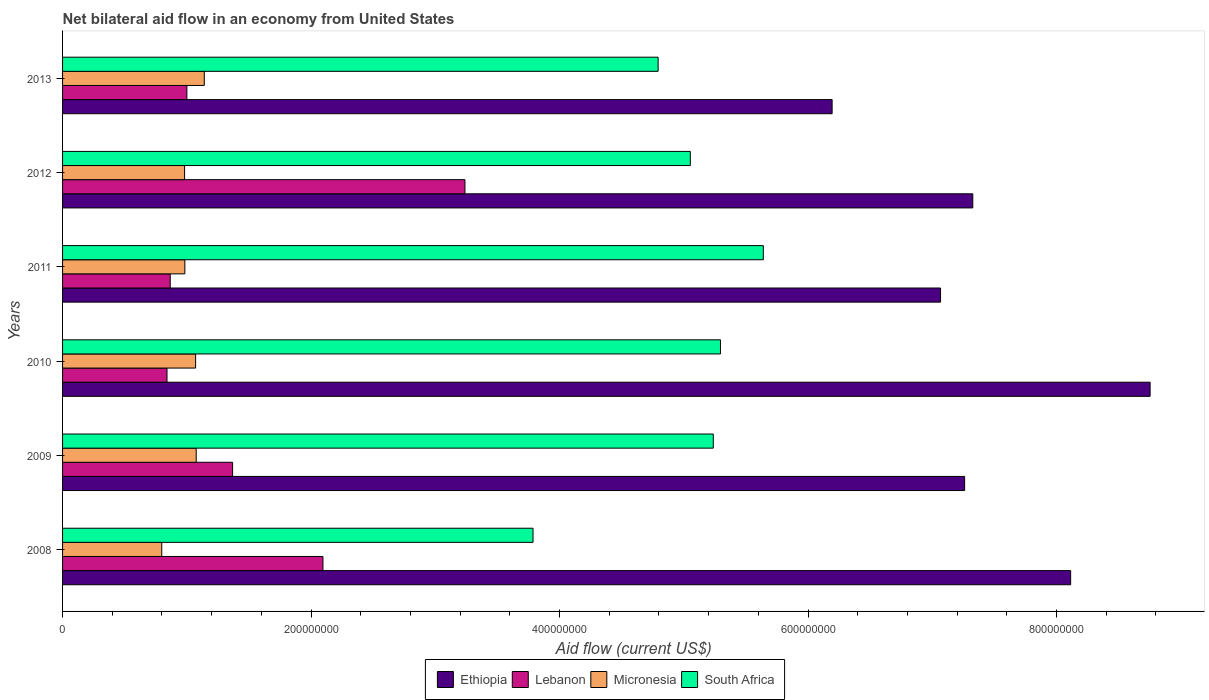How many groups of bars are there?
Make the answer very short. 6. Are the number of bars per tick equal to the number of legend labels?
Give a very brief answer. Yes. How many bars are there on the 1st tick from the top?
Keep it short and to the point. 4. What is the label of the 5th group of bars from the top?
Give a very brief answer. 2009. What is the net bilateral aid flow in Micronesia in 2013?
Your answer should be very brief. 1.14e+08. Across all years, what is the maximum net bilateral aid flow in Lebanon?
Make the answer very short. 3.24e+08. Across all years, what is the minimum net bilateral aid flow in Lebanon?
Offer a terse response. 8.40e+07. In which year was the net bilateral aid flow in South Africa minimum?
Offer a very short reply. 2008. What is the total net bilateral aid flow in Micronesia in the graph?
Make the answer very short. 6.05e+08. What is the difference between the net bilateral aid flow in Lebanon in 2008 and that in 2012?
Your answer should be compact. -1.14e+08. What is the difference between the net bilateral aid flow in Micronesia in 2009 and the net bilateral aid flow in Lebanon in 2011?
Provide a short and direct response. 2.09e+07. What is the average net bilateral aid flow in Lebanon per year?
Your answer should be very brief. 1.57e+08. In the year 2009, what is the difference between the net bilateral aid flow in Lebanon and net bilateral aid flow in Micronesia?
Offer a terse response. 2.93e+07. In how many years, is the net bilateral aid flow in Ethiopia greater than 560000000 US$?
Give a very brief answer. 6. What is the ratio of the net bilateral aid flow in Lebanon in 2011 to that in 2012?
Keep it short and to the point. 0.27. What is the difference between the highest and the second highest net bilateral aid flow in Micronesia?
Offer a very short reply. 6.52e+06. What is the difference between the highest and the lowest net bilateral aid flow in South Africa?
Offer a terse response. 1.85e+08. In how many years, is the net bilateral aid flow in South Africa greater than the average net bilateral aid flow in South Africa taken over all years?
Your answer should be very brief. 4. Is the sum of the net bilateral aid flow in Ethiopia in 2008 and 2012 greater than the maximum net bilateral aid flow in Micronesia across all years?
Make the answer very short. Yes. What does the 1st bar from the top in 2012 represents?
Offer a terse response. South Africa. What does the 1st bar from the bottom in 2012 represents?
Offer a terse response. Ethiopia. Are all the bars in the graph horizontal?
Provide a short and direct response. Yes. Does the graph contain any zero values?
Your response must be concise. No. Where does the legend appear in the graph?
Make the answer very short. Bottom center. How many legend labels are there?
Keep it short and to the point. 4. How are the legend labels stacked?
Your answer should be very brief. Horizontal. What is the title of the graph?
Your answer should be very brief. Net bilateral aid flow in an economy from United States. What is the label or title of the X-axis?
Ensure brevity in your answer.  Aid flow (current US$). What is the label or title of the Y-axis?
Provide a succinct answer. Years. What is the Aid flow (current US$) in Ethiopia in 2008?
Your response must be concise. 8.11e+08. What is the Aid flow (current US$) in Lebanon in 2008?
Keep it short and to the point. 2.10e+08. What is the Aid flow (current US$) of Micronesia in 2008?
Offer a very short reply. 7.98e+07. What is the Aid flow (current US$) in South Africa in 2008?
Provide a short and direct response. 3.79e+08. What is the Aid flow (current US$) of Ethiopia in 2009?
Your answer should be compact. 7.26e+08. What is the Aid flow (current US$) in Lebanon in 2009?
Give a very brief answer. 1.37e+08. What is the Aid flow (current US$) of Micronesia in 2009?
Your answer should be compact. 1.08e+08. What is the Aid flow (current US$) in South Africa in 2009?
Give a very brief answer. 5.24e+08. What is the Aid flow (current US$) of Ethiopia in 2010?
Offer a very short reply. 8.75e+08. What is the Aid flow (current US$) of Lebanon in 2010?
Make the answer very short. 8.40e+07. What is the Aid flow (current US$) in Micronesia in 2010?
Offer a terse response. 1.07e+08. What is the Aid flow (current US$) of South Africa in 2010?
Make the answer very short. 5.30e+08. What is the Aid flow (current US$) of Ethiopia in 2011?
Provide a short and direct response. 7.07e+08. What is the Aid flow (current US$) of Lebanon in 2011?
Give a very brief answer. 8.67e+07. What is the Aid flow (current US$) in Micronesia in 2011?
Your response must be concise. 9.84e+07. What is the Aid flow (current US$) of South Africa in 2011?
Give a very brief answer. 5.64e+08. What is the Aid flow (current US$) of Ethiopia in 2012?
Your answer should be very brief. 7.33e+08. What is the Aid flow (current US$) of Lebanon in 2012?
Keep it short and to the point. 3.24e+08. What is the Aid flow (current US$) in Micronesia in 2012?
Keep it short and to the point. 9.82e+07. What is the Aid flow (current US$) of South Africa in 2012?
Make the answer very short. 5.05e+08. What is the Aid flow (current US$) of Ethiopia in 2013?
Your response must be concise. 6.19e+08. What is the Aid flow (current US$) of Lebanon in 2013?
Offer a very short reply. 1.00e+08. What is the Aid flow (current US$) of Micronesia in 2013?
Offer a terse response. 1.14e+08. What is the Aid flow (current US$) of South Africa in 2013?
Your answer should be very brief. 4.79e+08. Across all years, what is the maximum Aid flow (current US$) of Ethiopia?
Provide a short and direct response. 8.75e+08. Across all years, what is the maximum Aid flow (current US$) of Lebanon?
Provide a short and direct response. 3.24e+08. Across all years, what is the maximum Aid flow (current US$) of Micronesia?
Your response must be concise. 1.14e+08. Across all years, what is the maximum Aid flow (current US$) of South Africa?
Your answer should be very brief. 5.64e+08. Across all years, what is the minimum Aid flow (current US$) in Ethiopia?
Offer a very short reply. 6.19e+08. Across all years, what is the minimum Aid flow (current US$) in Lebanon?
Ensure brevity in your answer.  8.40e+07. Across all years, what is the minimum Aid flow (current US$) in Micronesia?
Give a very brief answer. 7.98e+07. Across all years, what is the minimum Aid flow (current US$) of South Africa?
Offer a terse response. 3.79e+08. What is the total Aid flow (current US$) in Ethiopia in the graph?
Provide a succinct answer. 4.47e+09. What is the total Aid flow (current US$) in Lebanon in the graph?
Make the answer very short. 9.41e+08. What is the total Aid flow (current US$) in Micronesia in the graph?
Give a very brief answer. 6.05e+08. What is the total Aid flow (current US$) of South Africa in the graph?
Offer a terse response. 2.98e+09. What is the difference between the Aid flow (current US$) of Ethiopia in 2008 and that in 2009?
Give a very brief answer. 8.53e+07. What is the difference between the Aid flow (current US$) in Lebanon in 2008 and that in 2009?
Provide a succinct answer. 7.27e+07. What is the difference between the Aid flow (current US$) in Micronesia in 2008 and that in 2009?
Keep it short and to the point. -2.77e+07. What is the difference between the Aid flow (current US$) of South Africa in 2008 and that in 2009?
Provide a short and direct response. -1.45e+08. What is the difference between the Aid flow (current US$) in Ethiopia in 2008 and that in 2010?
Your answer should be very brief. -6.40e+07. What is the difference between the Aid flow (current US$) in Lebanon in 2008 and that in 2010?
Offer a terse response. 1.26e+08. What is the difference between the Aid flow (current US$) in Micronesia in 2008 and that in 2010?
Ensure brevity in your answer.  -2.73e+07. What is the difference between the Aid flow (current US$) in South Africa in 2008 and that in 2010?
Provide a short and direct response. -1.51e+08. What is the difference between the Aid flow (current US$) of Ethiopia in 2008 and that in 2011?
Keep it short and to the point. 1.05e+08. What is the difference between the Aid flow (current US$) of Lebanon in 2008 and that in 2011?
Your answer should be compact. 1.23e+08. What is the difference between the Aid flow (current US$) of Micronesia in 2008 and that in 2011?
Keep it short and to the point. -1.86e+07. What is the difference between the Aid flow (current US$) of South Africa in 2008 and that in 2011?
Your response must be concise. -1.85e+08. What is the difference between the Aid flow (current US$) of Ethiopia in 2008 and that in 2012?
Give a very brief answer. 7.88e+07. What is the difference between the Aid flow (current US$) of Lebanon in 2008 and that in 2012?
Make the answer very short. -1.14e+08. What is the difference between the Aid flow (current US$) in Micronesia in 2008 and that in 2012?
Your answer should be very brief. -1.84e+07. What is the difference between the Aid flow (current US$) in South Africa in 2008 and that in 2012?
Offer a very short reply. -1.27e+08. What is the difference between the Aid flow (current US$) of Ethiopia in 2008 and that in 2013?
Your response must be concise. 1.92e+08. What is the difference between the Aid flow (current US$) of Lebanon in 2008 and that in 2013?
Ensure brevity in your answer.  1.10e+08. What is the difference between the Aid flow (current US$) in Micronesia in 2008 and that in 2013?
Ensure brevity in your answer.  -3.42e+07. What is the difference between the Aid flow (current US$) in South Africa in 2008 and that in 2013?
Provide a succinct answer. -1.01e+08. What is the difference between the Aid flow (current US$) in Ethiopia in 2009 and that in 2010?
Keep it short and to the point. -1.49e+08. What is the difference between the Aid flow (current US$) of Lebanon in 2009 and that in 2010?
Give a very brief answer. 5.28e+07. What is the difference between the Aid flow (current US$) in Micronesia in 2009 and that in 2010?
Ensure brevity in your answer.  4.60e+05. What is the difference between the Aid flow (current US$) in South Africa in 2009 and that in 2010?
Your response must be concise. -5.79e+06. What is the difference between the Aid flow (current US$) in Ethiopia in 2009 and that in 2011?
Offer a very short reply. 1.94e+07. What is the difference between the Aid flow (current US$) in Lebanon in 2009 and that in 2011?
Give a very brief answer. 5.02e+07. What is the difference between the Aid flow (current US$) in Micronesia in 2009 and that in 2011?
Ensure brevity in your answer.  9.14e+06. What is the difference between the Aid flow (current US$) of South Africa in 2009 and that in 2011?
Ensure brevity in your answer.  -4.03e+07. What is the difference between the Aid flow (current US$) of Ethiopia in 2009 and that in 2012?
Offer a very short reply. -6.57e+06. What is the difference between the Aid flow (current US$) in Lebanon in 2009 and that in 2012?
Offer a very short reply. -1.87e+08. What is the difference between the Aid flow (current US$) in Micronesia in 2009 and that in 2012?
Offer a terse response. 9.35e+06. What is the difference between the Aid flow (current US$) in South Africa in 2009 and that in 2012?
Give a very brief answer. 1.85e+07. What is the difference between the Aid flow (current US$) of Ethiopia in 2009 and that in 2013?
Ensure brevity in your answer.  1.07e+08. What is the difference between the Aid flow (current US$) in Lebanon in 2009 and that in 2013?
Your answer should be very brief. 3.68e+07. What is the difference between the Aid flow (current US$) of Micronesia in 2009 and that in 2013?
Keep it short and to the point. -6.52e+06. What is the difference between the Aid flow (current US$) of South Africa in 2009 and that in 2013?
Your answer should be compact. 4.44e+07. What is the difference between the Aid flow (current US$) in Ethiopia in 2010 and that in 2011?
Offer a very short reply. 1.69e+08. What is the difference between the Aid flow (current US$) of Lebanon in 2010 and that in 2011?
Your answer should be compact. -2.61e+06. What is the difference between the Aid flow (current US$) in Micronesia in 2010 and that in 2011?
Give a very brief answer. 8.68e+06. What is the difference between the Aid flow (current US$) of South Africa in 2010 and that in 2011?
Ensure brevity in your answer.  -3.45e+07. What is the difference between the Aid flow (current US$) of Ethiopia in 2010 and that in 2012?
Provide a succinct answer. 1.43e+08. What is the difference between the Aid flow (current US$) in Lebanon in 2010 and that in 2012?
Ensure brevity in your answer.  -2.40e+08. What is the difference between the Aid flow (current US$) of Micronesia in 2010 and that in 2012?
Offer a terse response. 8.89e+06. What is the difference between the Aid flow (current US$) in South Africa in 2010 and that in 2012?
Provide a short and direct response. 2.43e+07. What is the difference between the Aid flow (current US$) in Ethiopia in 2010 and that in 2013?
Your answer should be compact. 2.56e+08. What is the difference between the Aid flow (current US$) of Lebanon in 2010 and that in 2013?
Offer a terse response. -1.60e+07. What is the difference between the Aid flow (current US$) in Micronesia in 2010 and that in 2013?
Make the answer very short. -6.98e+06. What is the difference between the Aid flow (current US$) in South Africa in 2010 and that in 2013?
Keep it short and to the point. 5.02e+07. What is the difference between the Aid flow (current US$) of Ethiopia in 2011 and that in 2012?
Offer a terse response. -2.60e+07. What is the difference between the Aid flow (current US$) of Lebanon in 2011 and that in 2012?
Your response must be concise. -2.37e+08. What is the difference between the Aid flow (current US$) in Micronesia in 2011 and that in 2012?
Provide a succinct answer. 2.10e+05. What is the difference between the Aid flow (current US$) in South Africa in 2011 and that in 2012?
Provide a short and direct response. 5.88e+07. What is the difference between the Aid flow (current US$) of Ethiopia in 2011 and that in 2013?
Your answer should be compact. 8.73e+07. What is the difference between the Aid flow (current US$) in Lebanon in 2011 and that in 2013?
Your answer should be very brief. -1.34e+07. What is the difference between the Aid flow (current US$) in Micronesia in 2011 and that in 2013?
Provide a succinct answer. -1.57e+07. What is the difference between the Aid flow (current US$) of South Africa in 2011 and that in 2013?
Ensure brevity in your answer.  8.47e+07. What is the difference between the Aid flow (current US$) of Ethiopia in 2012 and that in 2013?
Offer a very short reply. 1.13e+08. What is the difference between the Aid flow (current US$) of Lebanon in 2012 and that in 2013?
Your answer should be very brief. 2.24e+08. What is the difference between the Aid flow (current US$) in Micronesia in 2012 and that in 2013?
Make the answer very short. -1.59e+07. What is the difference between the Aid flow (current US$) in South Africa in 2012 and that in 2013?
Offer a very short reply. 2.59e+07. What is the difference between the Aid flow (current US$) in Ethiopia in 2008 and the Aid flow (current US$) in Lebanon in 2009?
Your response must be concise. 6.75e+08. What is the difference between the Aid flow (current US$) in Ethiopia in 2008 and the Aid flow (current US$) in Micronesia in 2009?
Make the answer very short. 7.04e+08. What is the difference between the Aid flow (current US$) in Ethiopia in 2008 and the Aid flow (current US$) in South Africa in 2009?
Offer a very short reply. 2.88e+08. What is the difference between the Aid flow (current US$) of Lebanon in 2008 and the Aid flow (current US$) of Micronesia in 2009?
Offer a terse response. 1.02e+08. What is the difference between the Aid flow (current US$) in Lebanon in 2008 and the Aid flow (current US$) in South Africa in 2009?
Make the answer very short. -3.14e+08. What is the difference between the Aid flow (current US$) in Micronesia in 2008 and the Aid flow (current US$) in South Africa in 2009?
Give a very brief answer. -4.44e+08. What is the difference between the Aid flow (current US$) of Ethiopia in 2008 and the Aid flow (current US$) of Lebanon in 2010?
Your response must be concise. 7.27e+08. What is the difference between the Aid flow (current US$) in Ethiopia in 2008 and the Aid flow (current US$) in Micronesia in 2010?
Make the answer very short. 7.04e+08. What is the difference between the Aid flow (current US$) of Ethiopia in 2008 and the Aid flow (current US$) of South Africa in 2010?
Your answer should be very brief. 2.82e+08. What is the difference between the Aid flow (current US$) of Lebanon in 2008 and the Aid flow (current US$) of Micronesia in 2010?
Keep it short and to the point. 1.02e+08. What is the difference between the Aid flow (current US$) in Lebanon in 2008 and the Aid flow (current US$) in South Africa in 2010?
Your response must be concise. -3.20e+08. What is the difference between the Aid flow (current US$) of Micronesia in 2008 and the Aid flow (current US$) of South Africa in 2010?
Your answer should be compact. -4.50e+08. What is the difference between the Aid flow (current US$) in Ethiopia in 2008 and the Aid flow (current US$) in Lebanon in 2011?
Give a very brief answer. 7.25e+08. What is the difference between the Aid flow (current US$) of Ethiopia in 2008 and the Aid flow (current US$) of Micronesia in 2011?
Ensure brevity in your answer.  7.13e+08. What is the difference between the Aid flow (current US$) in Ethiopia in 2008 and the Aid flow (current US$) in South Africa in 2011?
Offer a very short reply. 2.47e+08. What is the difference between the Aid flow (current US$) of Lebanon in 2008 and the Aid flow (current US$) of Micronesia in 2011?
Your answer should be very brief. 1.11e+08. What is the difference between the Aid flow (current US$) in Lebanon in 2008 and the Aid flow (current US$) in South Africa in 2011?
Ensure brevity in your answer.  -3.54e+08. What is the difference between the Aid flow (current US$) of Micronesia in 2008 and the Aid flow (current US$) of South Africa in 2011?
Provide a short and direct response. -4.84e+08. What is the difference between the Aid flow (current US$) in Ethiopia in 2008 and the Aid flow (current US$) in Lebanon in 2012?
Give a very brief answer. 4.88e+08. What is the difference between the Aid flow (current US$) in Ethiopia in 2008 and the Aid flow (current US$) in Micronesia in 2012?
Keep it short and to the point. 7.13e+08. What is the difference between the Aid flow (current US$) of Ethiopia in 2008 and the Aid flow (current US$) of South Africa in 2012?
Your answer should be very brief. 3.06e+08. What is the difference between the Aid flow (current US$) of Lebanon in 2008 and the Aid flow (current US$) of Micronesia in 2012?
Make the answer very short. 1.11e+08. What is the difference between the Aid flow (current US$) of Lebanon in 2008 and the Aid flow (current US$) of South Africa in 2012?
Ensure brevity in your answer.  -2.96e+08. What is the difference between the Aid flow (current US$) of Micronesia in 2008 and the Aid flow (current US$) of South Africa in 2012?
Ensure brevity in your answer.  -4.25e+08. What is the difference between the Aid flow (current US$) of Ethiopia in 2008 and the Aid flow (current US$) of Lebanon in 2013?
Keep it short and to the point. 7.11e+08. What is the difference between the Aid flow (current US$) of Ethiopia in 2008 and the Aid flow (current US$) of Micronesia in 2013?
Provide a short and direct response. 6.97e+08. What is the difference between the Aid flow (current US$) of Ethiopia in 2008 and the Aid flow (current US$) of South Africa in 2013?
Provide a short and direct response. 3.32e+08. What is the difference between the Aid flow (current US$) in Lebanon in 2008 and the Aid flow (current US$) in Micronesia in 2013?
Offer a very short reply. 9.55e+07. What is the difference between the Aid flow (current US$) of Lebanon in 2008 and the Aid flow (current US$) of South Africa in 2013?
Give a very brief answer. -2.70e+08. What is the difference between the Aid flow (current US$) of Micronesia in 2008 and the Aid flow (current US$) of South Africa in 2013?
Provide a succinct answer. -4.00e+08. What is the difference between the Aid flow (current US$) of Ethiopia in 2009 and the Aid flow (current US$) of Lebanon in 2010?
Ensure brevity in your answer.  6.42e+08. What is the difference between the Aid flow (current US$) of Ethiopia in 2009 and the Aid flow (current US$) of Micronesia in 2010?
Keep it short and to the point. 6.19e+08. What is the difference between the Aid flow (current US$) of Ethiopia in 2009 and the Aid flow (current US$) of South Africa in 2010?
Offer a terse response. 1.97e+08. What is the difference between the Aid flow (current US$) in Lebanon in 2009 and the Aid flow (current US$) in Micronesia in 2010?
Offer a terse response. 2.98e+07. What is the difference between the Aid flow (current US$) in Lebanon in 2009 and the Aid flow (current US$) in South Africa in 2010?
Offer a very short reply. -3.93e+08. What is the difference between the Aid flow (current US$) of Micronesia in 2009 and the Aid flow (current US$) of South Africa in 2010?
Keep it short and to the point. -4.22e+08. What is the difference between the Aid flow (current US$) of Ethiopia in 2009 and the Aid flow (current US$) of Lebanon in 2011?
Your response must be concise. 6.39e+08. What is the difference between the Aid flow (current US$) of Ethiopia in 2009 and the Aid flow (current US$) of Micronesia in 2011?
Your answer should be very brief. 6.28e+08. What is the difference between the Aid flow (current US$) in Ethiopia in 2009 and the Aid flow (current US$) in South Africa in 2011?
Keep it short and to the point. 1.62e+08. What is the difference between the Aid flow (current US$) of Lebanon in 2009 and the Aid flow (current US$) of Micronesia in 2011?
Give a very brief answer. 3.84e+07. What is the difference between the Aid flow (current US$) in Lebanon in 2009 and the Aid flow (current US$) in South Africa in 2011?
Make the answer very short. -4.27e+08. What is the difference between the Aid flow (current US$) of Micronesia in 2009 and the Aid flow (current US$) of South Africa in 2011?
Your answer should be compact. -4.56e+08. What is the difference between the Aid flow (current US$) in Ethiopia in 2009 and the Aid flow (current US$) in Lebanon in 2012?
Offer a terse response. 4.02e+08. What is the difference between the Aid flow (current US$) in Ethiopia in 2009 and the Aid flow (current US$) in Micronesia in 2012?
Your response must be concise. 6.28e+08. What is the difference between the Aid flow (current US$) in Ethiopia in 2009 and the Aid flow (current US$) in South Africa in 2012?
Make the answer very short. 2.21e+08. What is the difference between the Aid flow (current US$) of Lebanon in 2009 and the Aid flow (current US$) of Micronesia in 2012?
Your answer should be compact. 3.86e+07. What is the difference between the Aid flow (current US$) of Lebanon in 2009 and the Aid flow (current US$) of South Africa in 2012?
Your answer should be compact. -3.68e+08. What is the difference between the Aid flow (current US$) of Micronesia in 2009 and the Aid flow (current US$) of South Africa in 2012?
Provide a short and direct response. -3.98e+08. What is the difference between the Aid flow (current US$) in Ethiopia in 2009 and the Aid flow (current US$) in Lebanon in 2013?
Your answer should be very brief. 6.26e+08. What is the difference between the Aid flow (current US$) of Ethiopia in 2009 and the Aid flow (current US$) of Micronesia in 2013?
Make the answer very short. 6.12e+08. What is the difference between the Aid flow (current US$) of Ethiopia in 2009 and the Aid flow (current US$) of South Africa in 2013?
Offer a very short reply. 2.47e+08. What is the difference between the Aid flow (current US$) in Lebanon in 2009 and the Aid flow (current US$) in Micronesia in 2013?
Your answer should be very brief. 2.28e+07. What is the difference between the Aid flow (current US$) of Lebanon in 2009 and the Aid flow (current US$) of South Africa in 2013?
Give a very brief answer. -3.42e+08. What is the difference between the Aid flow (current US$) of Micronesia in 2009 and the Aid flow (current US$) of South Africa in 2013?
Provide a succinct answer. -3.72e+08. What is the difference between the Aid flow (current US$) of Ethiopia in 2010 and the Aid flow (current US$) of Lebanon in 2011?
Your answer should be very brief. 7.89e+08. What is the difference between the Aid flow (current US$) of Ethiopia in 2010 and the Aid flow (current US$) of Micronesia in 2011?
Make the answer very short. 7.77e+08. What is the difference between the Aid flow (current US$) of Ethiopia in 2010 and the Aid flow (current US$) of South Africa in 2011?
Ensure brevity in your answer.  3.11e+08. What is the difference between the Aid flow (current US$) in Lebanon in 2010 and the Aid flow (current US$) in Micronesia in 2011?
Your response must be concise. -1.44e+07. What is the difference between the Aid flow (current US$) of Lebanon in 2010 and the Aid flow (current US$) of South Africa in 2011?
Offer a very short reply. -4.80e+08. What is the difference between the Aid flow (current US$) in Micronesia in 2010 and the Aid flow (current US$) in South Africa in 2011?
Provide a short and direct response. -4.57e+08. What is the difference between the Aid flow (current US$) in Ethiopia in 2010 and the Aid flow (current US$) in Lebanon in 2012?
Your answer should be very brief. 5.51e+08. What is the difference between the Aid flow (current US$) in Ethiopia in 2010 and the Aid flow (current US$) in Micronesia in 2012?
Your answer should be compact. 7.77e+08. What is the difference between the Aid flow (current US$) of Ethiopia in 2010 and the Aid flow (current US$) of South Africa in 2012?
Your answer should be compact. 3.70e+08. What is the difference between the Aid flow (current US$) of Lebanon in 2010 and the Aid flow (current US$) of Micronesia in 2012?
Offer a terse response. -1.42e+07. What is the difference between the Aid flow (current US$) in Lebanon in 2010 and the Aid flow (current US$) in South Africa in 2012?
Your answer should be very brief. -4.21e+08. What is the difference between the Aid flow (current US$) of Micronesia in 2010 and the Aid flow (current US$) of South Africa in 2012?
Provide a succinct answer. -3.98e+08. What is the difference between the Aid flow (current US$) in Ethiopia in 2010 and the Aid flow (current US$) in Lebanon in 2013?
Give a very brief answer. 7.75e+08. What is the difference between the Aid flow (current US$) of Ethiopia in 2010 and the Aid flow (current US$) of Micronesia in 2013?
Ensure brevity in your answer.  7.61e+08. What is the difference between the Aid flow (current US$) of Ethiopia in 2010 and the Aid flow (current US$) of South Africa in 2013?
Your answer should be compact. 3.96e+08. What is the difference between the Aid flow (current US$) of Lebanon in 2010 and the Aid flow (current US$) of Micronesia in 2013?
Ensure brevity in your answer.  -3.00e+07. What is the difference between the Aid flow (current US$) in Lebanon in 2010 and the Aid flow (current US$) in South Africa in 2013?
Ensure brevity in your answer.  -3.95e+08. What is the difference between the Aid flow (current US$) in Micronesia in 2010 and the Aid flow (current US$) in South Africa in 2013?
Offer a terse response. -3.72e+08. What is the difference between the Aid flow (current US$) in Ethiopia in 2011 and the Aid flow (current US$) in Lebanon in 2012?
Your answer should be compact. 3.83e+08. What is the difference between the Aid flow (current US$) in Ethiopia in 2011 and the Aid flow (current US$) in Micronesia in 2012?
Your response must be concise. 6.08e+08. What is the difference between the Aid flow (current US$) in Ethiopia in 2011 and the Aid flow (current US$) in South Africa in 2012?
Offer a terse response. 2.01e+08. What is the difference between the Aid flow (current US$) of Lebanon in 2011 and the Aid flow (current US$) of Micronesia in 2012?
Provide a short and direct response. -1.16e+07. What is the difference between the Aid flow (current US$) in Lebanon in 2011 and the Aid flow (current US$) in South Africa in 2012?
Your answer should be compact. -4.19e+08. What is the difference between the Aid flow (current US$) of Micronesia in 2011 and the Aid flow (current US$) of South Africa in 2012?
Give a very brief answer. -4.07e+08. What is the difference between the Aid flow (current US$) in Ethiopia in 2011 and the Aid flow (current US$) in Lebanon in 2013?
Make the answer very short. 6.07e+08. What is the difference between the Aid flow (current US$) of Ethiopia in 2011 and the Aid flow (current US$) of Micronesia in 2013?
Offer a terse response. 5.93e+08. What is the difference between the Aid flow (current US$) in Ethiopia in 2011 and the Aid flow (current US$) in South Africa in 2013?
Make the answer very short. 2.27e+08. What is the difference between the Aid flow (current US$) in Lebanon in 2011 and the Aid flow (current US$) in Micronesia in 2013?
Offer a terse response. -2.74e+07. What is the difference between the Aid flow (current US$) of Lebanon in 2011 and the Aid flow (current US$) of South Africa in 2013?
Provide a succinct answer. -3.93e+08. What is the difference between the Aid flow (current US$) of Micronesia in 2011 and the Aid flow (current US$) of South Africa in 2013?
Offer a very short reply. -3.81e+08. What is the difference between the Aid flow (current US$) in Ethiopia in 2012 and the Aid flow (current US$) in Lebanon in 2013?
Keep it short and to the point. 6.33e+08. What is the difference between the Aid flow (current US$) of Ethiopia in 2012 and the Aid flow (current US$) of Micronesia in 2013?
Provide a short and direct response. 6.19e+08. What is the difference between the Aid flow (current US$) of Ethiopia in 2012 and the Aid flow (current US$) of South Africa in 2013?
Give a very brief answer. 2.53e+08. What is the difference between the Aid flow (current US$) of Lebanon in 2012 and the Aid flow (current US$) of Micronesia in 2013?
Offer a very short reply. 2.10e+08. What is the difference between the Aid flow (current US$) in Lebanon in 2012 and the Aid flow (current US$) in South Africa in 2013?
Keep it short and to the point. -1.55e+08. What is the difference between the Aid flow (current US$) in Micronesia in 2012 and the Aid flow (current US$) in South Africa in 2013?
Your answer should be compact. -3.81e+08. What is the average Aid flow (current US$) of Ethiopia per year?
Give a very brief answer. 7.45e+08. What is the average Aid flow (current US$) in Lebanon per year?
Ensure brevity in your answer.  1.57e+08. What is the average Aid flow (current US$) in Micronesia per year?
Your response must be concise. 1.01e+08. What is the average Aid flow (current US$) of South Africa per year?
Your response must be concise. 4.97e+08. In the year 2008, what is the difference between the Aid flow (current US$) of Ethiopia and Aid flow (current US$) of Lebanon?
Your answer should be very brief. 6.02e+08. In the year 2008, what is the difference between the Aid flow (current US$) of Ethiopia and Aid flow (current US$) of Micronesia?
Provide a short and direct response. 7.32e+08. In the year 2008, what is the difference between the Aid flow (current US$) in Ethiopia and Aid flow (current US$) in South Africa?
Keep it short and to the point. 4.33e+08. In the year 2008, what is the difference between the Aid flow (current US$) in Lebanon and Aid flow (current US$) in Micronesia?
Ensure brevity in your answer.  1.30e+08. In the year 2008, what is the difference between the Aid flow (current US$) in Lebanon and Aid flow (current US$) in South Africa?
Offer a very short reply. -1.69e+08. In the year 2008, what is the difference between the Aid flow (current US$) of Micronesia and Aid flow (current US$) of South Africa?
Your response must be concise. -2.99e+08. In the year 2009, what is the difference between the Aid flow (current US$) of Ethiopia and Aid flow (current US$) of Lebanon?
Provide a short and direct response. 5.89e+08. In the year 2009, what is the difference between the Aid flow (current US$) in Ethiopia and Aid flow (current US$) in Micronesia?
Keep it short and to the point. 6.18e+08. In the year 2009, what is the difference between the Aid flow (current US$) in Ethiopia and Aid flow (current US$) in South Africa?
Your response must be concise. 2.02e+08. In the year 2009, what is the difference between the Aid flow (current US$) in Lebanon and Aid flow (current US$) in Micronesia?
Offer a very short reply. 2.93e+07. In the year 2009, what is the difference between the Aid flow (current US$) of Lebanon and Aid flow (current US$) of South Africa?
Provide a succinct answer. -3.87e+08. In the year 2009, what is the difference between the Aid flow (current US$) in Micronesia and Aid flow (current US$) in South Africa?
Keep it short and to the point. -4.16e+08. In the year 2010, what is the difference between the Aid flow (current US$) in Ethiopia and Aid flow (current US$) in Lebanon?
Offer a very short reply. 7.91e+08. In the year 2010, what is the difference between the Aid flow (current US$) of Ethiopia and Aid flow (current US$) of Micronesia?
Offer a very short reply. 7.68e+08. In the year 2010, what is the difference between the Aid flow (current US$) in Ethiopia and Aid flow (current US$) in South Africa?
Offer a terse response. 3.46e+08. In the year 2010, what is the difference between the Aid flow (current US$) of Lebanon and Aid flow (current US$) of Micronesia?
Provide a succinct answer. -2.30e+07. In the year 2010, what is the difference between the Aid flow (current US$) in Lebanon and Aid flow (current US$) in South Africa?
Give a very brief answer. -4.45e+08. In the year 2010, what is the difference between the Aid flow (current US$) in Micronesia and Aid flow (current US$) in South Africa?
Provide a succinct answer. -4.22e+08. In the year 2011, what is the difference between the Aid flow (current US$) in Ethiopia and Aid flow (current US$) in Lebanon?
Make the answer very short. 6.20e+08. In the year 2011, what is the difference between the Aid flow (current US$) of Ethiopia and Aid flow (current US$) of Micronesia?
Offer a terse response. 6.08e+08. In the year 2011, what is the difference between the Aid flow (current US$) of Ethiopia and Aid flow (current US$) of South Africa?
Ensure brevity in your answer.  1.43e+08. In the year 2011, what is the difference between the Aid flow (current US$) in Lebanon and Aid flow (current US$) in Micronesia?
Offer a terse response. -1.18e+07. In the year 2011, what is the difference between the Aid flow (current US$) in Lebanon and Aid flow (current US$) in South Africa?
Provide a short and direct response. -4.77e+08. In the year 2011, what is the difference between the Aid flow (current US$) in Micronesia and Aid flow (current US$) in South Africa?
Provide a succinct answer. -4.66e+08. In the year 2012, what is the difference between the Aid flow (current US$) in Ethiopia and Aid flow (current US$) in Lebanon?
Provide a short and direct response. 4.09e+08. In the year 2012, what is the difference between the Aid flow (current US$) in Ethiopia and Aid flow (current US$) in Micronesia?
Your answer should be compact. 6.34e+08. In the year 2012, what is the difference between the Aid flow (current US$) of Ethiopia and Aid flow (current US$) of South Africa?
Your answer should be compact. 2.27e+08. In the year 2012, what is the difference between the Aid flow (current US$) of Lebanon and Aid flow (current US$) of Micronesia?
Provide a succinct answer. 2.26e+08. In the year 2012, what is the difference between the Aid flow (current US$) in Lebanon and Aid flow (current US$) in South Africa?
Offer a terse response. -1.81e+08. In the year 2012, what is the difference between the Aid flow (current US$) in Micronesia and Aid flow (current US$) in South Africa?
Your response must be concise. -4.07e+08. In the year 2013, what is the difference between the Aid flow (current US$) of Ethiopia and Aid flow (current US$) of Lebanon?
Your answer should be compact. 5.19e+08. In the year 2013, what is the difference between the Aid flow (current US$) in Ethiopia and Aid flow (current US$) in Micronesia?
Offer a terse response. 5.05e+08. In the year 2013, what is the difference between the Aid flow (current US$) in Ethiopia and Aid flow (current US$) in South Africa?
Offer a very short reply. 1.40e+08. In the year 2013, what is the difference between the Aid flow (current US$) of Lebanon and Aid flow (current US$) of Micronesia?
Provide a short and direct response. -1.40e+07. In the year 2013, what is the difference between the Aid flow (current US$) in Lebanon and Aid flow (current US$) in South Africa?
Keep it short and to the point. -3.79e+08. In the year 2013, what is the difference between the Aid flow (current US$) in Micronesia and Aid flow (current US$) in South Africa?
Your answer should be compact. -3.65e+08. What is the ratio of the Aid flow (current US$) of Ethiopia in 2008 to that in 2009?
Make the answer very short. 1.12. What is the ratio of the Aid flow (current US$) of Lebanon in 2008 to that in 2009?
Make the answer very short. 1.53. What is the ratio of the Aid flow (current US$) of Micronesia in 2008 to that in 2009?
Make the answer very short. 0.74. What is the ratio of the Aid flow (current US$) in South Africa in 2008 to that in 2009?
Provide a succinct answer. 0.72. What is the ratio of the Aid flow (current US$) of Ethiopia in 2008 to that in 2010?
Ensure brevity in your answer.  0.93. What is the ratio of the Aid flow (current US$) of Lebanon in 2008 to that in 2010?
Offer a terse response. 2.49. What is the ratio of the Aid flow (current US$) of Micronesia in 2008 to that in 2010?
Give a very brief answer. 0.75. What is the ratio of the Aid flow (current US$) of South Africa in 2008 to that in 2010?
Ensure brevity in your answer.  0.72. What is the ratio of the Aid flow (current US$) of Ethiopia in 2008 to that in 2011?
Provide a short and direct response. 1.15. What is the ratio of the Aid flow (current US$) of Lebanon in 2008 to that in 2011?
Your answer should be very brief. 2.42. What is the ratio of the Aid flow (current US$) of Micronesia in 2008 to that in 2011?
Offer a very short reply. 0.81. What is the ratio of the Aid flow (current US$) of South Africa in 2008 to that in 2011?
Keep it short and to the point. 0.67. What is the ratio of the Aid flow (current US$) of Ethiopia in 2008 to that in 2012?
Ensure brevity in your answer.  1.11. What is the ratio of the Aid flow (current US$) of Lebanon in 2008 to that in 2012?
Your answer should be very brief. 0.65. What is the ratio of the Aid flow (current US$) of Micronesia in 2008 to that in 2012?
Your answer should be compact. 0.81. What is the ratio of the Aid flow (current US$) of South Africa in 2008 to that in 2012?
Make the answer very short. 0.75. What is the ratio of the Aid flow (current US$) of Ethiopia in 2008 to that in 2013?
Offer a terse response. 1.31. What is the ratio of the Aid flow (current US$) in Lebanon in 2008 to that in 2013?
Ensure brevity in your answer.  2.09. What is the ratio of the Aid flow (current US$) in Micronesia in 2008 to that in 2013?
Ensure brevity in your answer.  0.7. What is the ratio of the Aid flow (current US$) of South Africa in 2008 to that in 2013?
Provide a short and direct response. 0.79. What is the ratio of the Aid flow (current US$) of Ethiopia in 2009 to that in 2010?
Your answer should be very brief. 0.83. What is the ratio of the Aid flow (current US$) in Lebanon in 2009 to that in 2010?
Ensure brevity in your answer.  1.63. What is the ratio of the Aid flow (current US$) in Ethiopia in 2009 to that in 2011?
Ensure brevity in your answer.  1.03. What is the ratio of the Aid flow (current US$) in Lebanon in 2009 to that in 2011?
Keep it short and to the point. 1.58. What is the ratio of the Aid flow (current US$) in Micronesia in 2009 to that in 2011?
Your answer should be very brief. 1.09. What is the ratio of the Aid flow (current US$) of Ethiopia in 2009 to that in 2012?
Make the answer very short. 0.99. What is the ratio of the Aid flow (current US$) of Lebanon in 2009 to that in 2012?
Your response must be concise. 0.42. What is the ratio of the Aid flow (current US$) in Micronesia in 2009 to that in 2012?
Your answer should be very brief. 1.1. What is the ratio of the Aid flow (current US$) in South Africa in 2009 to that in 2012?
Ensure brevity in your answer.  1.04. What is the ratio of the Aid flow (current US$) in Ethiopia in 2009 to that in 2013?
Provide a succinct answer. 1.17. What is the ratio of the Aid flow (current US$) of Lebanon in 2009 to that in 2013?
Make the answer very short. 1.37. What is the ratio of the Aid flow (current US$) in Micronesia in 2009 to that in 2013?
Ensure brevity in your answer.  0.94. What is the ratio of the Aid flow (current US$) of South Africa in 2009 to that in 2013?
Provide a short and direct response. 1.09. What is the ratio of the Aid flow (current US$) in Ethiopia in 2010 to that in 2011?
Ensure brevity in your answer.  1.24. What is the ratio of the Aid flow (current US$) of Lebanon in 2010 to that in 2011?
Provide a succinct answer. 0.97. What is the ratio of the Aid flow (current US$) in Micronesia in 2010 to that in 2011?
Offer a terse response. 1.09. What is the ratio of the Aid flow (current US$) in South Africa in 2010 to that in 2011?
Keep it short and to the point. 0.94. What is the ratio of the Aid flow (current US$) of Ethiopia in 2010 to that in 2012?
Offer a very short reply. 1.19. What is the ratio of the Aid flow (current US$) in Lebanon in 2010 to that in 2012?
Your response must be concise. 0.26. What is the ratio of the Aid flow (current US$) in Micronesia in 2010 to that in 2012?
Ensure brevity in your answer.  1.09. What is the ratio of the Aid flow (current US$) in South Africa in 2010 to that in 2012?
Ensure brevity in your answer.  1.05. What is the ratio of the Aid flow (current US$) of Ethiopia in 2010 to that in 2013?
Make the answer very short. 1.41. What is the ratio of the Aid flow (current US$) of Lebanon in 2010 to that in 2013?
Ensure brevity in your answer.  0.84. What is the ratio of the Aid flow (current US$) in Micronesia in 2010 to that in 2013?
Make the answer very short. 0.94. What is the ratio of the Aid flow (current US$) in South Africa in 2010 to that in 2013?
Give a very brief answer. 1.1. What is the ratio of the Aid flow (current US$) of Ethiopia in 2011 to that in 2012?
Your answer should be very brief. 0.96. What is the ratio of the Aid flow (current US$) of Lebanon in 2011 to that in 2012?
Provide a short and direct response. 0.27. What is the ratio of the Aid flow (current US$) of Micronesia in 2011 to that in 2012?
Provide a short and direct response. 1. What is the ratio of the Aid flow (current US$) of South Africa in 2011 to that in 2012?
Give a very brief answer. 1.12. What is the ratio of the Aid flow (current US$) of Ethiopia in 2011 to that in 2013?
Your answer should be compact. 1.14. What is the ratio of the Aid flow (current US$) of Lebanon in 2011 to that in 2013?
Make the answer very short. 0.87. What is the ratio of the Aid flow (current US$) of Micronesia in 2011 to that in 2013?
Your answer should be very brief. 0.86. What is the ratio of the Aid flow (current US$) in South Africa in 2011 to that in 2013?
Keep it short and to the point. 1.18. What is the ratio of the Aid flow (current US$) in Ethiopia in 2012 to that in 2013?
Your answer should be very brief. 1.18. What is the ratio of the Aid flow (current US$) of Lebanon in 2012 to that in 2013?
Provide a short and direct response. 3.24. What is the ratio of the Aid flow (current US$) in Micronesia in 2012 to that in 2013?
Keep it short and to the point. 0.86. What is the ratio of the Aid flow (current US$) of South Africa in 2012 to that in 2013?
Your answer should be very brief. 1.05. What is the difference between the highest and the second highest Aid flow (current US$) of Ethiopia?
Offer a very short reply. 6.40e+07. What is the difference between the highest and the second highest Aid flow (current US$) in Lebanon?
Provide a succinct answer. 1.14e+08. What is the difference between the highest and the second highest Aid flow (current US$) in Micronesia?
Your response must be concise. 6.52e+06. What is the difference between the highest and the second highest Aid flow (current US$) in South Africa?
Provide a succinct answer. 3.45e+07. What is the difference between the highest and the lowest Aid flow (current US$) in Ethiopia?
Keep it short and to the point. 2.56e+08. What is the difference between the highest and the lowest Aid flow (current US$) of Lebanon?
Your answer should be very brief. 2.40e+08. What is the difference between the highest and the lowest Aid flow (current US$) in Micronesia?
Offer a terse response. 3.42e+07. What is the difference between the highest and the lowest Aid flow (current US$) in South Africa?
Keep it short and to the point. 1.85e+08. 